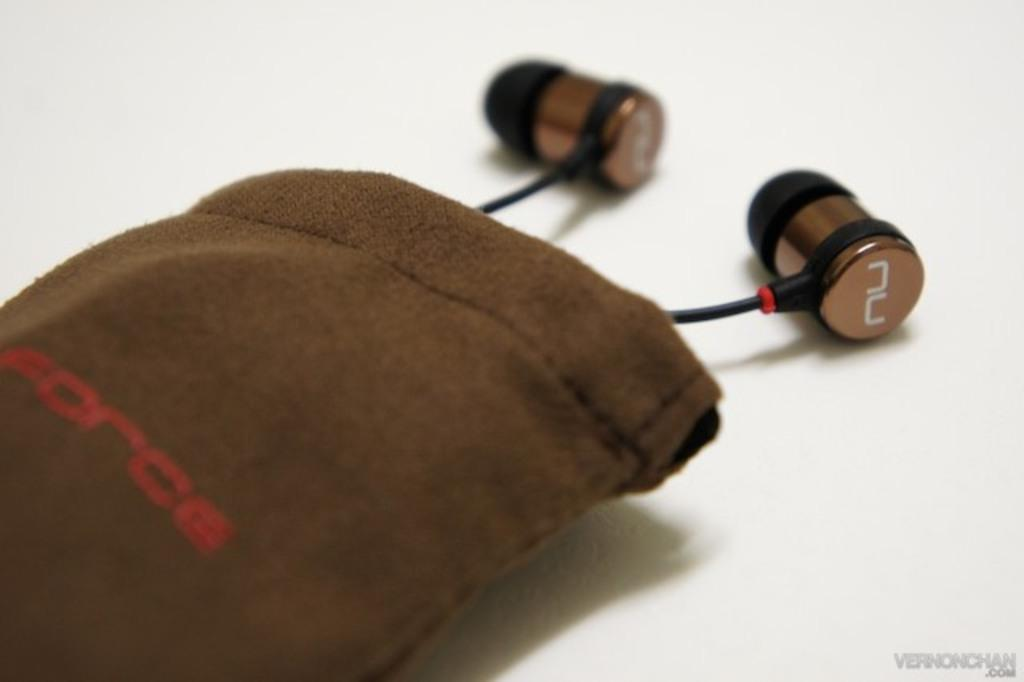What is the main object in the center of the image? There is a pouch in the center of the image. What color is the pouch? The pouch is brown in color. Is there any text or writing on the pouch? Yes, there is writing on the pouch. What can be found inside the pouch? Earphones are present inside the pouch. What type of meat is being prepared in the cemetery in the image? There is no cemetery or meat present in the image; it features a brown pouch with writing and earphones inside. 